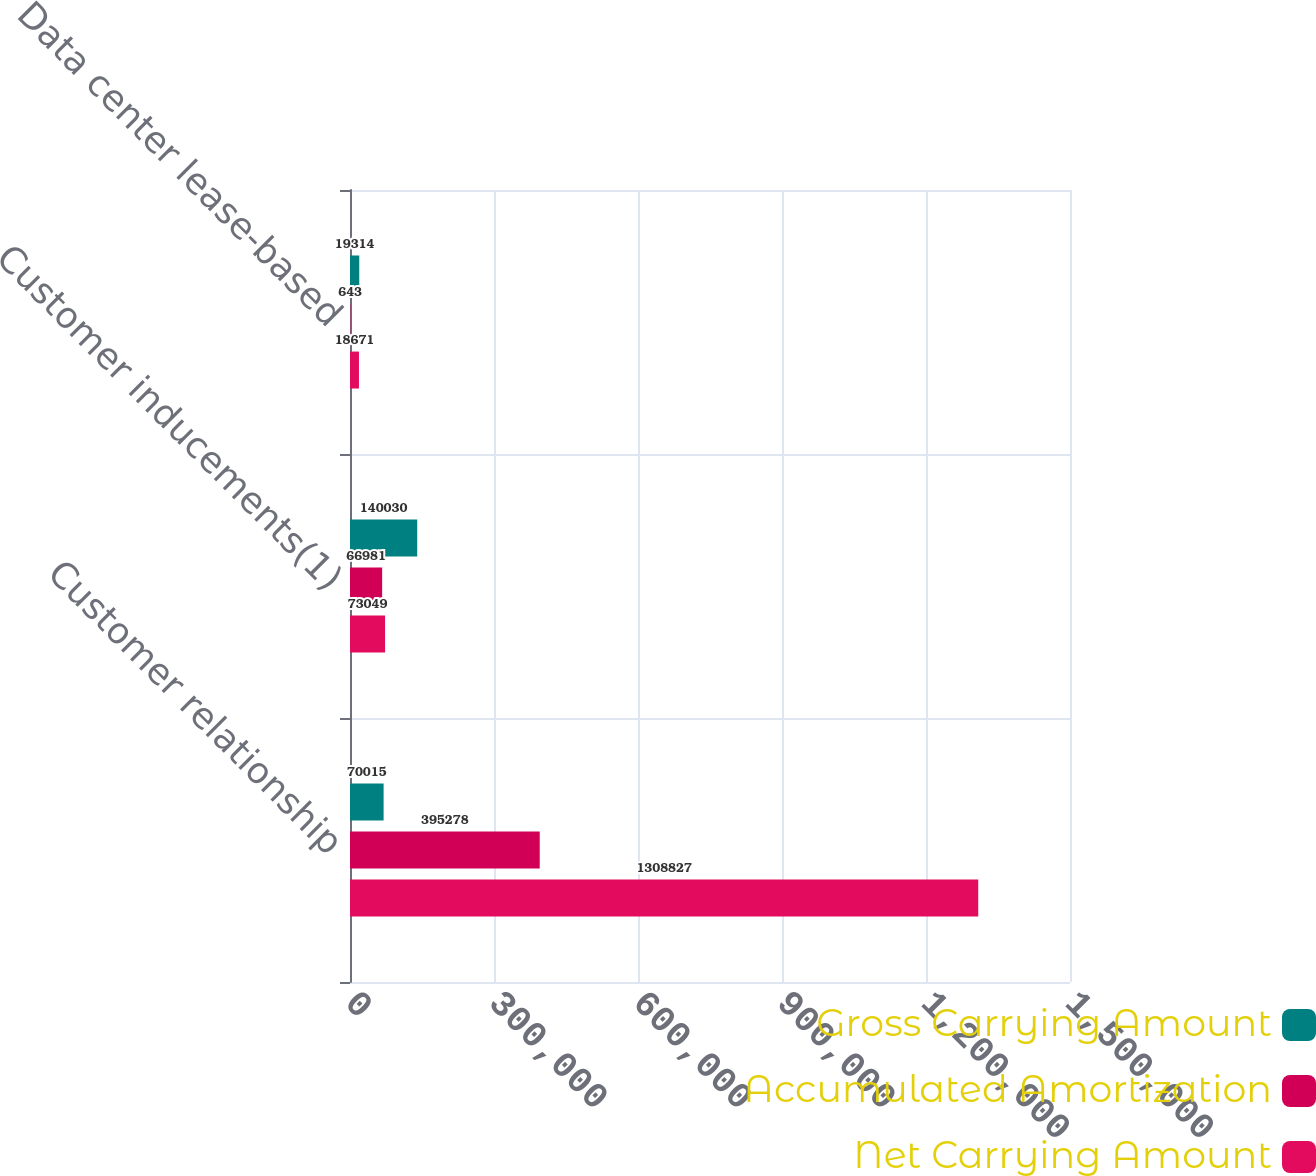<chart> <loc_0><loc_0><loc_500><loc_500><stacked_bar_chart><ecel><fcel>Customer relationship<fcel>Customer inducements(1)<fcel>Data center lease-based<nl><fcel>Gross Carrying Amount<fcel>70015<fcel>140030<fcel>19314<nl><fcel>Accumulated Amortization<fcel>395278<fcel>66981<fcel>643<nl><fcel>Net Carrying Amount<fcel>1.30883e+06<fcel>73049<fcel>18671<nl></chart> 